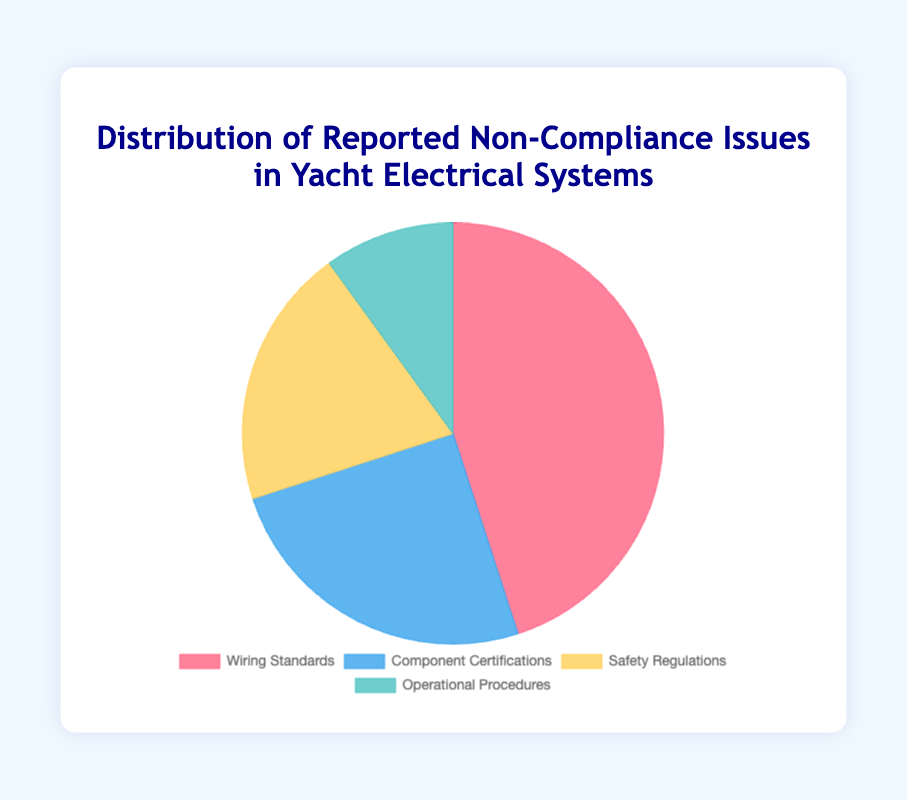What type of non-compliance issue has the highest number of reported issues? The type of non-compliance issue with the highest number of reported issues is the one with the greatest number in the pie chart. By looking at the chart, Wiring Standards has the highest proportion.
Answer: Wiring Standards What is the percentage of reported issues attributed to Safety Regulations? First, find the total number of reported issues: 45 (Wiring Standards) + 25 (Component Certifications) + 20 (Safety Regulations) + 10 (Operational Procedures) = 100. Then, calculate the percentage for Safety Regulations: (20/100) * 100 = 20%.
Answer: 20% How many more reported issues are there for Wiring Standards compared to Operational Procedures? The number of reported issues for Wiring Standards is 45, and for Operational Procedures is 10. The difference is calculated as 45 - 10 = 35.
Answer: 35 Among the non-compliance issues listed, which one has the least number of reported issues? The type of non-compliance issue with the least number of reported issues is the smallest portion in the pie chart. Operational Procedures has the smallest proportion.
Answer: Operational Procedures What is the ratio of Component Certifications issues to Safety Regulations issues? The number of reported issues for Component Certifications is 25, and for Safety Regulations, it is 20. The ratio is 25:20, which can be simplified to 5:4.
Answer: 5:4 What percentage of the reported issues is due to either Wiring Standards or Component Certifications? First, sum the reported issues for Wiring Standards and Component Certifications: 45 (Wiring Standards) + 25 (Component Certifications) = 70. Then, calculate the percentage: (70/100) * 100 = 70%.
Answer: 70% Are there more reported issues for Component Certifications or Operational Procedures, and by how much? The number of reported issues for Component Certifications is 25, and for Operational Procedures, it is 10. The difference is calculated as 25 - 10 = 15.
Answer: Component Certifications, 15 How do the reported issues for Safety Regulations compare to those for Operational Procedures? The number of reported issues for Safety Regulations is 20, and for Operational Procedures, it is 10. Safety Regulations have twice as many reported issues as Operational Procedures (20/10 = 2).
Answer: Safety Regulations has twice the issues What's the cumulative number of reported issues for Operational Procedures and Safety Regulations? The number of reported issues for Operational Procedures is 10, and for Safety Regulations, it is 20. The cumulative number is calculated as 10 + 20 = 30.
Answer: 30 